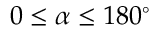<formula> <loc_0><loc_0><loc_500><loc_500>0 \leq \alpha \leq 1 8 0 ^ { \circ }</formula> 